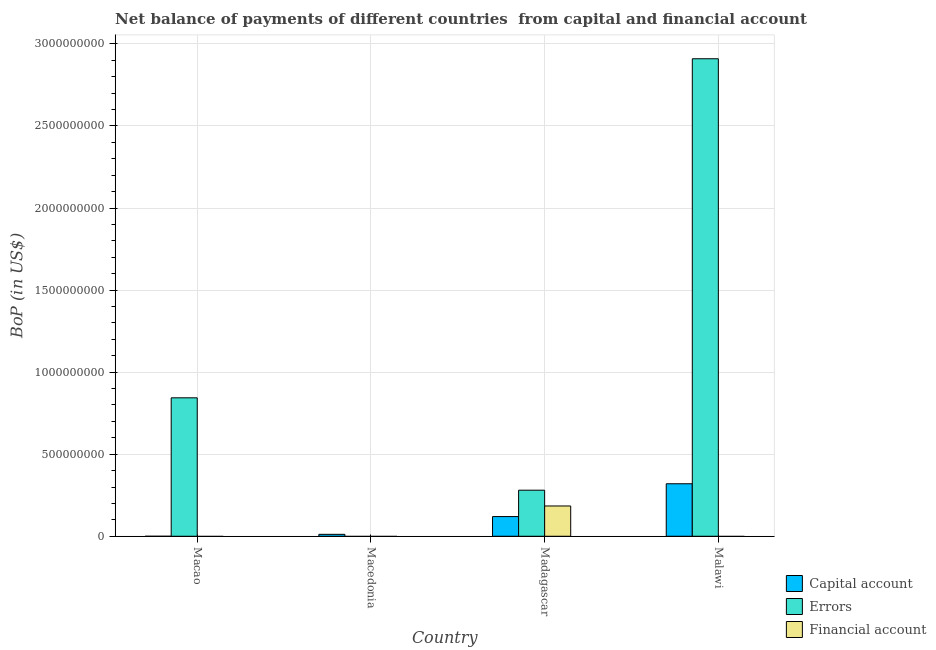Are the number of bars per tick equal to the number of legend labels?
Offer a terse response. No. Are the number of bars on each tick of the X-axis equal?
Keep it short and to the point. No. What is the label of the 2nd group of bars from the left?
Give a very brief answer. Macedonia. What is the amount of net capital account in Macedonia?
Provide a succinct answer. 1.17e+07. Across all countries, what is the maximum amount of errors?
Your answer should be very brief. 2.91e+09. Across all countries, what is the minimum amount of financial account?
Provide a succinct answer. 0. In which country was the amount of net capital account maximum?
Your answer should be compact. Malawi. What is the total amount of errors in the graph?
Provide a short and direct response. 4.03e+09. What is the difference between the amount of net capital account in Macedonia and that in Malawi?
Your answer should be very brief. -3.08e+08. What is the difference between the amount of net capital account in Madagascar and the amount of financial account in Macedonia?
Your response must be concise. 1.20e+08. What is the average amount of errors per country?
Your answer should be compact. 1.01e+09. What is the difference between the amount of financial account and amount of net capital account in Madagascar?
Your response must be concise. 6.46e+07. In how many countries, is the amount of financial account greater than 1600000000 US$?
Your answer should be compact. 0. What is the ratio of the amount of errors in Macao to that in Malawi?
Offer a very short reply. 0.29. What is the difference between the highest and the second highest amount of net capital account?
Keep it short and to the point. 2.00e+08. What is the difference between the highest and the lowest amount of net capital account?
Make the answer very short. 3.20e+08. Is the sum of the amount of net capital account in Macedonia and Madagascar greater than the maximum amount of financial account across all countries?
Ensure brevity in your answer.  No. How many countries are there in the graph?
Your response must be concise. 4. What is the difference between two consecutive major ticks on the Y-axis?
Give a very brief answer. 5.00e+08. Are the values on the major ticks of Y-axis written in scientific E-notation?
Your response must be concise. No. Does the graph contain grids?
Make the answer very short. Yes. Where does the legend appear in the graph?
Provide a short and direct response. Bottom right. How many legend labels are there?
Provide a succinct answer. 3. How are the legend labels stacked?
Your answer should be very brief. Vertical. What is the title of the graph?
Your answer should be very brief. Net balance of payments of different countries  from capital and financial account. Does "Transport equipments" appear as one of the legend labels in the graph?
Your response must be concise. No. What is the label or title of the X-axis?
Your answer should be very brief. Country. What is the label or title of the Y-axis?
Provide a succinct answer. BoP (in US$). What is the BoP (in US$) in Errors in Macao?
Your answer should be very brief. 8.44e+08. What is the BoP (in US$) in Capital account in Macedonia?
Provide a short and direct response. 1.17e+07. What is the BoP (in US$) of Errors in Macedonia?
Your response must be concise. 0. What is the BoP (in US$) of Financial account in Macedonia?
Offer a terse response. 0. What is the BoP (in US$) of Capital account in Madagascar?
Offer a very short reply. 1.20e+08. What is the BoP (in US$) of Errors in Madagascar?
Give a very brief answer. 2.81e+08. What is the BoP (in US$) in Financial account in Madagascar?
Give a very brief answer. 1.84e+08. What is the BoP (in US$) of Capital account in Malawi?
Ensure brevity in your answer.  3.20e+08. What is the BoP (in US$) of Errors in Malawi?
Your response must be concise. 2.91e+09. What is the BoP (in US$) in Financial account in Malawi?
Provide a short and direct response. 0. Across all countries, what is the maximum BoP (in US$) of Capital account?
Make the answer very short. 3.20e+08. Across all countries, what is the maximum BoP (in US$) of Errors?
Give a very brief answer. 2.91e+09. Across all countries, what is the maximum BoP (in US$) of Financial account?
Make the answer very short. 1.84e+08. Across all countries, what is the minimum BoP (in US$) in Capital account?
Give a very brief answer. 0. What is the total BoP (in US$) of Capital account in the graph?
Provide a short and direct response. 4.52e+08. What is the total BoP (in US$) of Errors in the graph?
Provide a succinct answer. 4.03e+09. What is the total BoP (in US$) of Financial account in the graph?
Ensure brevity in your answer.  1.84e+08. What is the difference between the BoP (in US$) of Errors in Macao and that in Madagascar?
Your answer should be compact. 5.63e+08. What is the difference between the BoP (in US$) in Errors in Macao and that in Malawi?
Offer a terse response. -2.07e+09. What is the difference between the BoP (in US$) of Capital account in Macedonia and that in Madagascar?
Provide a short and direct response. -1.08e+08. What is the difference between the BoP (in US$) of Capital account in Macedonia and that in Malawi?
Keep it short and to the point. -3.08e+08. What is the difference between the BoP (in US$) in Capital account in Madagascar and that in Malawi?
Keep it short and to the point. -2.00e+08. What is the difference between the BoP (in US$) in Errors in Madagascar and that in Malawi?
Provide a succinct answer. -2.63e+09. What is the difference between the BoP (in US$) of Errors in Macao and the BoP (in US$) of Financial account in Madagascar?
Keep it short and to the point. 6.59e+08. What is the difference between the BoP (in US$) in Capital account in Macedonia and the BoP (in US$) in Errors in Madagascar?
Ensure brevity in your answer.  -2.69e+08. What is the difference between the BoP (in US$) of Capital account in Macedonia and the BoP (in US$) of Financial account in Madagascar?
Offer a very short reply. -1.73e+08. What is the difference between the BoP (in US$) of Capital account in Macedonia and the BoP (in US$) of Errors in Malawi?
Make the answer very short. -2.90e+09. What is the difference between the BoP (in US$) in Capital account in Madagascar and the BoP (in US$) in Errors in Malawi?
Offer a very short reply. -2.79e+09. What is the average BoP (in US$) in Capital account per country?
Provide a succinct answer. 1.13e+08. What is the average BoP (in US$) in Errors per country?
Offer a very short reply. 1.01e+09. What is the average BoP (in US$) of Financial account per country?
Your answer should be compact. 4.61e+07. What is the difference between the BoP (in US$) in Capital account and BoP (in US$) in Errors in Madagascar?
Ensure brevity in your answer.  -1.61e+08. What is the difference between the BoP (in US$) in Capital account and BoP (in US$) in Financial account in Madagascar?
Your response must be concise. -6.46e+07. What is the difference between the BoP (in US$) in Errors and BoP (in US$) in Financial account in Madagascar?
Keep it short and to the point. 9.62e+07. What is the difference between the BoP (in US$) in Capital account and BoP (in US$) in Errors in Malawi?
Give a very brief answer. -2.59e+09. What is the ratio of the BoP (in US$) of Errors in Macao to that in Madagascar?
Your response must be concise. 3.01. What is the ratio of the BoP (in US$) in Errors in Macao to that in Malawi?
Give a very brief answer. 0.29. What is the ratio of the BoP (in US$) in Capital account in Macedonia to that in Madagascar?
Your answer should be very brief. 0.1. What is the ratio of the BoP (in US$) in Capital account in Macedonia to that in Malawi?
Your response must be concise. 0.04. What is the ratio of the BoP (in US$) of Capital account in Madagascar to that in Malawi?
Provide a succinct answer. 0.37. What is the ratio of the BoP (in US$) of Errors in Madagascar to that in Malawi?
Offer a very short reply. 0.1. What is the difference between the highest and the second highest BoP (in US$) of Capital account?
Make the answer very short. 2.00e+08. What is the difference between the highest and the second highest BoP (in US$) in Errors?
Your response must be concise. 2.07e+09. What is the difference between the highest and the lowest BoP (in US$) in Capital account?
Offer a very short reply. 3.20e+08. What is the difference between the highest and the lowest BoP (in US$) of Errors?
Your answer should be compact. 2.91e+09. What is the difference between the highest and the lowest BoP (in US$) of Financial account?
Your answer should be very brief. 1.84e+08. 